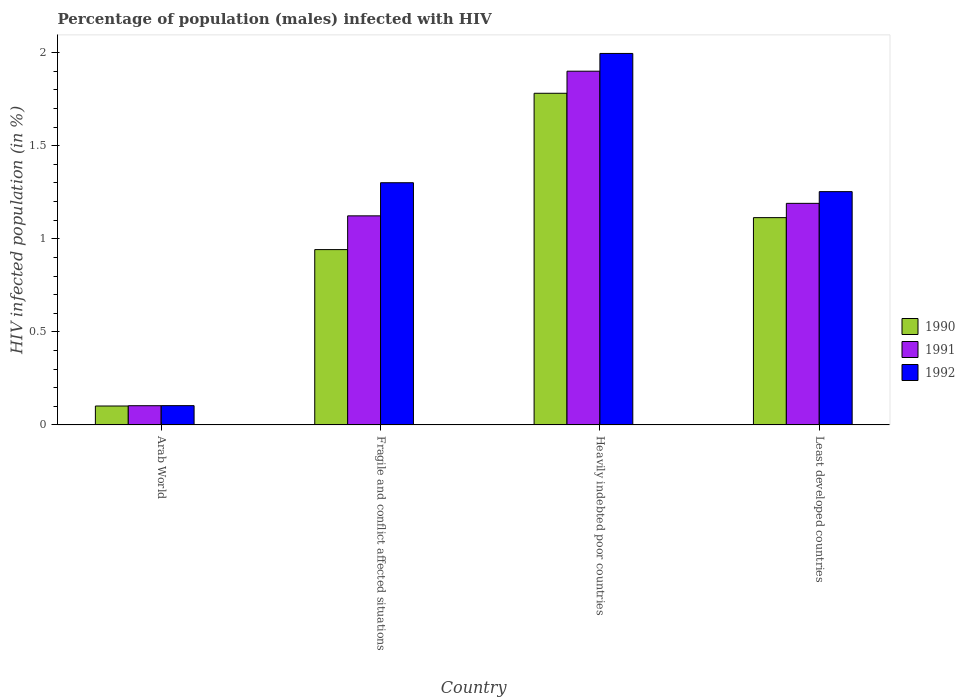How many different coloured bars are there?
Provide a succinct answer. 3. How many groups of bars are there?
Offer a very short reply. 4. Are the number of bars on each tick of the X-axis equal?
Ensure brevity in your answer.  Yes. How many bars are there on the 2nd tick from the right?
Your answer should be compact. 3. What is the label of the 2nd group of bars from the left?
Make the answer very short. Fragile and conflict affected situations. In how many cases, is the number of bars for a given country not equal to the number of legend labels?
Your response must be concise. 0. What is the percentage of HIV infected male population in 1991 in Arab World?
Keep it short and to the point. 0.1. Across all countries, what is the maximum percentage of HIV infected male population in 1990?
Make the answer very short. 1.78. Across all countries, what is the minimum percentage of HIV infected male population in 1991?
Keep it short and to the point. 0.1. In which country was the percentage of HIV infected male population in 1991 maximum?
Keep it short and to the point. Heavily indebted poor countries. In which country was the percentage of HIV infected male population in 1991 minimum?
Keep it short and to the point. Arab World. What is the total percentage of HIV infected male population in 1992 in the graph?
Offer a very short reply. 4.65. What is the difference between the percentage of HIV infected male population in 1991 in Fragile and conflict affected situations and that in Heavily indebted poor countries?
Offer a very short reply. -0.78. What is the difference between the percentage of HIV infected male population in 1990 in Least developed countries and the percentage of HIV infected male population in 1991 in Heavily indebted poor countries?
Make the answer very short. -0.79. What is the average percentage of HIV infected male population in 1990 per country?
Your response must be concise. 0.98. What is the difference between the percentage of HIV infected male population of/in 1991 and percentage of HIV infected male population of/in 1990 in Heavily indebted poor countries?
Offer a very short reply. 0.12. In how many countries, is the percentage of HIV infected male population in 1992 greater than 0.1 %?
Provide a succinct answer. 4. What is the ratio of the percentage of HIV infected male population in 1990 in Arab World to that in Fragile and conflict affected situations?
Offer a terse response. 0.11. What is the difference between the highest and the second highest percentage of HIV infected male population in 1990?
Offer a terse response. -0.84. What is the difference between the highest and the lowest percentage of HIV infected male population in 1992?
Offer a terse response. 1.89. In how many countries, is the percentage of HIV infected male population in 1990 greater than the average percentage of HIV infected male population in 1990 taken over all countries?
Offer a very short reply. 2. What does the 2nd bar from the right in Least developed countries represents?
Ensure brevity in your answer.  1991. Are all the bars in the graph horizontal?
Ensure brevity in your answer.  No. What is the difference between two consecutive major ticks on the Y-axis?
Ensure brevity in your answer.  0.5. Are the values on the major ticks of Y-axis written in scientific E-notation?
Keep it short and to the point. No. Does the graph contain any zero values?
Ensure brevity in your answer.  No. Does the graph contain grids?
Keep it short and to the point. No. Where does the legend appear in the graph?
Keep it short and to the point. Center right. How are the legend labels stacked?
Keep it short and to the point. Vertical. What is the title of the graph?
Your answer should be very brief. Percentage of population (males) infected with HIV. Does "1983" appear as one of the legend labels in the graph?
Ensure brevity in your answer.  No. What is the label or title of the X-axis?
Your answer should be compact. Country. What is the label or title of the Y-axis?
Ensure brevity in your answer.  HIV infected population (in %). What is the HIV infected population (in %) in 1990 in Arab World?
Keep it short and to the point. 0.1. What is the HIV infected population (in %) of 1991 in Arab World?
Provide a succinct answer. 0.1. What is the HIV infected population (in %) of 1992 in Arab World?
Offer a very short reply. 0.1. What is the HIV infected population (in %) of 1990 in Fragile and conflict affected situations?
Your answer should be compact. 0.94. What is the HIV infected population (in %) in 1991 in Fragile and conflict affected situations?
Give a very brief answer. 1.12. What is the HIV infected population (in %) of 1992 in Fragile and conflict affected situations?
Offer a very short reply. 1.3. What is the HIV infected population (in %) in 1990 in Heavily indebted poor countries?
Your response must be concise. 1.78. What is the HIV infected population (in %) in 1991 in Heavily indebted poor countries?
Offer a very short reply. 1.9. What is the HIV infected population (in %) of 1992 in Heavily indebted poor countries?
Offer a very short reply. 2. What is the HIV infected population (in %) of 1990 in Least developed countries?
Provide a succinct answer. 1.11. What is the HIV infected population (in %) of 1991 in Least developed countries?
Your answer should be very brief. 1.19. What is the HIV infected population (in %) of 1992 in Least developed countries?
Ensure brevity in your answer.  1.25. Across all countries, what is the maximum HIV infected population (in %) of 1990?
Offer a terse response. 1.78. Across all countries, what is the maximum HIV infected population (in %) of 1991?
Give a very brief answer. 1.9. Across all countries, what is the maximum HIV infected population (in %) of 1992?
Provide a succinct answer. 2. Across all countries, what is the minimum HIV infected population (in %) in 1990?
Keep it short and to the point. 0.1. Across all countries, what is the minimum HIV infected population (in %) of 1991?
Ensure brevity in your answer.  0.1. Across all countries, what is the minimum HIV infected population (in %) of 1992?
Ensure brevity in your answer.  0.1. What is the total HIV infected population (in %) in 1990 in the graph?
Your response must be concise. 3.94. What is the total HIV infected population (in %) of 1991 in the graph?
Your response must be concise. 4.32. What is the total HIV infected population (in %) of 1992 in the graph?
Provide a short and direct response. 4.65. What is the difference between the HIV infected population (in %) of 1990 in Arab World and that in Fragile and conflict affected situations?
Your answer should be compact. -0.84. What is the difference between the HIV infected population (in %) in 1991 in Arab World and that in Fragile and conflict affected situations?
Your response must be concise. -1.02. What is the difference between the HIV infected population (in %) in 1992 in Arab World and that in Fragile and conflict affected situations?
Your answer should be very brief. -1.2. What is the difference between the HIV infected population (in %) of 1990 in Arab World and that in Heavily indebted poor countries?
Keep it short and to the point. -1.68. What is the difference between the HIV infected population (in %) of 1991 in Arab World and that in Heavily indebted poor countries?
Offer a very short reply. -1.8. What is the difference between the HIV infected population (in %) of 1992 in Arab World and that in Heavily indebted poor countries?
Keep it short and to the point. -1.89. What is the difference between the HIV infected population (in %) of 1990 in Arab World and that in Least developed countries?
Offer a terse response. -1.01. What is the difference between the HIV infected population (in %) of 1991 in Arab World and that in Least developed countries?
Give a very brief answer. -1.09. What is the difference between the HIV infected population (in %) in 1992 in Arab World and that in Least developed countries?
Make the answer very short. -1.15. What is the difference between the HIV infected population (in %) in 1990 in Fragile and conflict affected situations and that in Heavily indebted poor countries?
Offer a terse response. -0.84. What is the difference between the HIV infected population (in %) of 1991 in Fragile and conflict affected situations and that in Heavily indebted poor countries?
Provide a short and direct response. -0.78. What is the difference between the HIV infected population (in %) in 1992 in Fragile and conflict affected situations and that in Heavily indebted poor countries?
Give a very brief answer. -0.69. What is the difference between the HIV infected population (in %) of 1990 in Fragile and conflict affected situations and that in Least developed countries?
Your answer should be compact. -0.17. What is the difference between the HIV infected population (in %) in 1991 in Fragile and conflict affected situations and that in Least developed countries?
Keep it short and to the point. -0.07. What is the difference between the HIV infected population (in %) in 1992 in Fragile and conflict affected situations and that in Least developed countries?
Keep it short and to the point. 0.05. What is the difference between the HIV infected population (in %) in 1990 in Heavily indebted poor countries and that in Least developed countries?
Ensure brevity in your answer.  0.67. What is the difference between the HIV infected population (in %) of 1991 in Heavily indebted poor countries and that in Least developed countries?
Ensure brevity in your answer.  0.71. What is the difference between the HIV infected population (in %) in 1992 in Heavily indebted poor countries and that in Least developed countries?
Your answer should be compact. 0.74. What is the difference between the HIV infected population (in %) of 1990 in Arab World and the HIV infected population (in %) of 1991 in Fragile and conflict affected situations?
Make the answer very short. -1.02. What is the difference between the HIV infected population (in %) in 1990 in Arab World and the HIV infected population (in %) in 1992 in Fragile and conflict affected situations?
Ensure brevity in your answer.  -1.2. What is the difference between the HIV infected population (in %) in 1991 in Arab World and the HIV infected population (in %) in 1992 in Fragile and conflict affected situations?
Keep it short and to the point. -1.2. What is the difference between the HIV infected population (in %) in 1990 in Arab World and the HIV infected population (in %) in 1991 in Heavily indebted poor countries?
Your answer should be compact. -1.8. What is the difference between the HIV infected population (in %) of 1990 in Arab World and the HIV infected population (in %) of 1992 in Heavily indebted poor countries?
Provide a succinct answer. -1.89. What is the difference between the HIV infected population (in %) in 1991 in Arab World and the HIV infected population (in %) in 1992 in Heavily indebted poor countries?
Your response must be concise. -1.89. What is the difference between the HIV infected population (in %) of 1990 in Arab World and the HIV infected population (in %) of 1991 in Least developed countries?
Ensure brevity in your answer.  -1.09. What is the difference between the HIV infected population (in %) of 1990 in Arab World and the HIV infected population (in %) of 1992 in Least developed countries?
Offer a terse response. -1.15. What is the difference between the HIV infected population (in %) in 1991 in Arab World and the HIV infected population (in %) in 1992 in Least developed countries?
Your answer should be compact. -1.15. What is the difference between the HIV infected population (in %) of 1990 in Fragile and conflict affected situations and the HIV infected population (in %) of 1991 in Heavily indebted poor countries?
Make the answer very short. -0.96. What is the difference between the HIV infected population (in %) of 1990 in Fragile and conflict affected situations and the HIV infected population (in %) of 1992 in Heavily indebted poor countries?
Provide a short and direct response. -1.05. What is the difference between the HIV infected population (in %) in 1991 in Fragile and conflict affected situations and the HIV infected population (in %) in 1992 in Heavily indebted poor countries?
Offer a terse response. -0.87. What is the difference between the HIV infected population (in %) of 1990 in Fragile and conflict affected situations and the HIV infected population (in %) of 1991 in Least developed countries?
Keep it short and to the point. -0.25. What is the difference between the HIV infected population (in %) of 1990 in Fragile and conflict affected situations and the HIV infected population (in %) of 1992 in Least developed countries?
Provide a succinct answer. -0.31. What is the difference between the HIV infected population (in %) in 1991 in Fragile and conflict affected situations and the HIV infected population (in %) in 1992 in Least developed countries?
Provide a short and direct response. -0.13. What is the difference between the HIV infected population (in %) in 1990 in Heavily indebted poor countries and the HIV infected population (in %) in 1991 in Least developed countries?
Provide a short and direct response. 0.59. What is the difference between the HIV infected population (in %) in 1990 in Heavily indebted poor countries and the HIV infected population (in %) in 1992 in Least developed countries?
Make the answer very short. 0.53. What is the difference between the HIV infected population (in %) in 1991 in Heavily indebted poor countries and the HIV infected population (in %) in 1992 in Least developed countries?
Provide a short and direct response. 0.65. What is the average HIV infected population (in %) in 1990 per country?
Provide a short and direct response. 0.98. What is the average HIV infected population (in %) of 1991 per country?
Provide a short and direct response. 1.08. What is the average HIV infected population (in %) in 1992 per country?
Your answer should be compact. 1.16. What is the difference between the HIV infected population (in %) of 1990 and HIV infected population (in %) of 1991 in Arab World?
Make the answer very short. -0. What is the difference between the HIV infected population (in %) of 1990 and HIV infected population (in %) of 1992 in Arab World?
Your answer should be compact. -0. What is the difference between the HIV infected population (in %) in 1991 and HIV infected population (in %) in 1992 in Arab World?
Make the answer very short. -0. What is the difference between the HIV infected population (in %) in 1990 and HIV infected population (in %) in 1991 in Fragile and conflict affected situations?
Your response must be concise. -0.18. What is the difference between the HIV infected population (in %) in 1990 and HIV infected population (in %) in 1992 in Fragile and conflict affected situations?
Your answer should be very brief. -0.36. What is the difference between the HIV infected population (in %) of 1991 and HIV infected population (in %) of 1992 in Fragile and conflict affected situations?
Provide a short and direct response. -0.18. What is the difference between the HIV infected population (in %) of 1990 and HIV infected population (in %) of 1991 in Heavily indebted poor countries?
Your answer should be very brief. -0.12. What is the difference between the HIV infected population (in %) of 1990 and HIV infected population (in %) of 1992 in Heavily indebted poor countries?
Ensure brevity in your answer.  -0.21. What is the difference between the HIV infected population (in %) of 1991 and HIV infected population (in %) of 1992 in Heavily indebted poor countries?
Keep it short and to the point. -0.1. What is the difference between the HIV infected population (in %) of 1990 and HIV infected population (in %) of 1991 in Least developed countries?
Ensure brevity in your answer.  -0.08. What is the difference between the HIV infected population (in %) in 1990 and HIV infected population (in %) in 1992 in Least developed countries?
Your answer should be very brief. -0.14. What is the difference between the HIV infected population (in %) in 1991 and HIV infected population (in %) in 1992 in Least developed countries?
Keep it short and to the point. -0.06. What is the ratio of the HIV infected population (in %) in 1990 in Arab World to that in Fragile and conflict affected situations?
Give a very brief answer. 0.11. What is the ratio of the HIV infected population (in %) of 1991 in Arab World to that in Fragile and conflict affected situations?
Offer a very short reply. 0.09. What is the ratio of the HIV infected population (in %) in 1992 in Arab World to that in Fragile and conflict affected situations?
Ensure brevity in your answer.  0.08. What is the ratio of the HIV infected population (in %) of 1990 in Arab World to that in Heavily indebted poor countries?
Keep it short and to the point. 0.06. What is the ratio of the HIV infected population (in %) of 1991 in Arab World to that in Heavily indebted poor countries?
Your response must be concise. 0.05. What is the ratio of the HIV infected population (in %) of 1992 in Arab World to that in Heavily indebted poor countries?
Keep it short and to the point. 0.05. What is the ratio of the HIV infected population (in %) in 1990 in Arab World to that in Least developed countries?
Provide a short and direct response. 0.09. What is the ratio of the HIV infected population (in %) in 1991 in Arab World to that in Least developed countries?
Provide a succinct answer. 0.09. What is the ratio of the HIV infected population (in %) in 1992 in Arab World to that in Least developed countries?
Give a very brief answer. 0.08. What is the ratio of the HIV infected population (in %) of 1990 in Fragile and conflict affected situations to that in Heavily indebted poor countries?
Your response must be concise. 0.53. What is the ratio of the HIV infected population (in %) of 1991 in Fragile and conflict affected situations to that in Heavily indebted poor countries?
Provide a short and direct response. 0.59. What is the ratio of the HIV infected population (in %) of 1992 in Fragile and conflict affected situations to that in Heavily indebted poor countries?
Your answer should be compact. 0.65. What is the ratio of the HIV infected population (in %) of 1990 in Fragile and conflict affected situations to that in Least developed countries?
Your response must be concise. 0.85. What is the ratio of the HIV infected population (in %) in 1991 in Fragile and conflict affected situations to that in Least developed countries?
Provide a short and direct response. 0.94. What is the ratio of the HIV infected population (in %) in 1992 in Fragile and conflict affected situations to that in Least developed countries?
Your answer should be compact. 1.04. What is the ratio of the HIV infected population (in %) in 1990 in Heavily indebted poor countries to that in Least developed countries?
Give a very brief answer. 1.6. What is the ratio of the HIV infected population (in %) in 1991 in Heavily indebted poor countries to that in Least developed countries?
Offer a terse response. 1.6. What is the ratio of the HIV infected population (in %) of 1992 in Heavily indebted poor countries to that in Least developed countries?
Keep it short and to the point. 1.59. What is the difference between the highest and the second highest HIV infected population (in %) of 1990?
Your answer should be very brief. 0.67. What is the difference between the highest and the second highest HIV infected population (in %) in 1991?
Ensure brevity in your answer.  0.71. What is the difference between the highest and the second highest HIV infected population (in %) in 1992?
Keep it short and to the point. 0.69. What is the difference between the highest and the lowest HIV infected population (in %) of 1990?
Offer a terse response. 1.68. What is the difference between the highest and the lowest HIV infected population (in %) of 1991?
Your answer should be compact. 1.8. What is the difference between the highest and the lowest HIV infected population (in %) of 1992?
Keep it short and to the point. 1.89. 